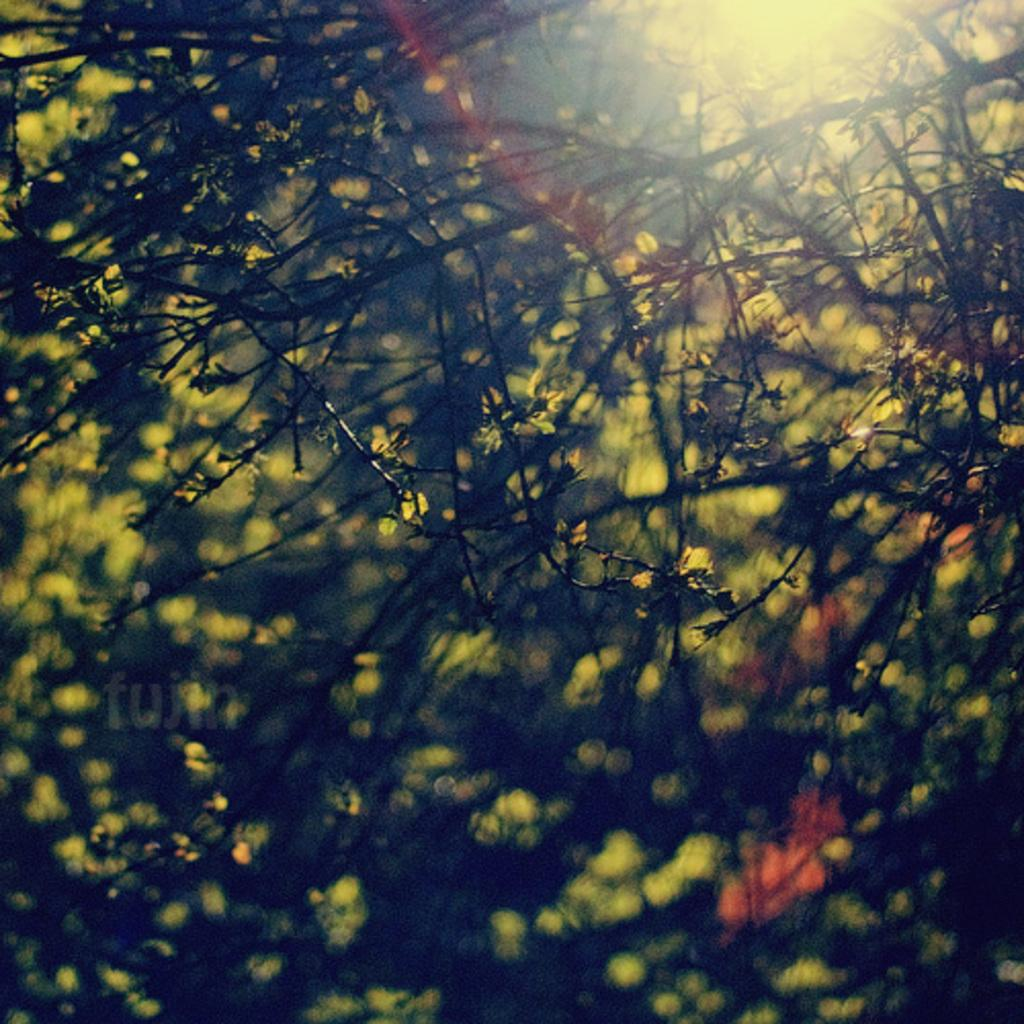What type of plant is depicted in the image? The image shows stems of a plant, but it does not specify the type of plant. What else can be seen on the left side of the image? There is some text visible on the left side of the image. How would you describe the background of the image? The background of the image appears blurry. How many apples are hanging from the plant in the image? There are no apples visible in the image; it only shows the stems of a plant. What type of house is shown in the image? There is no house present in the image. 